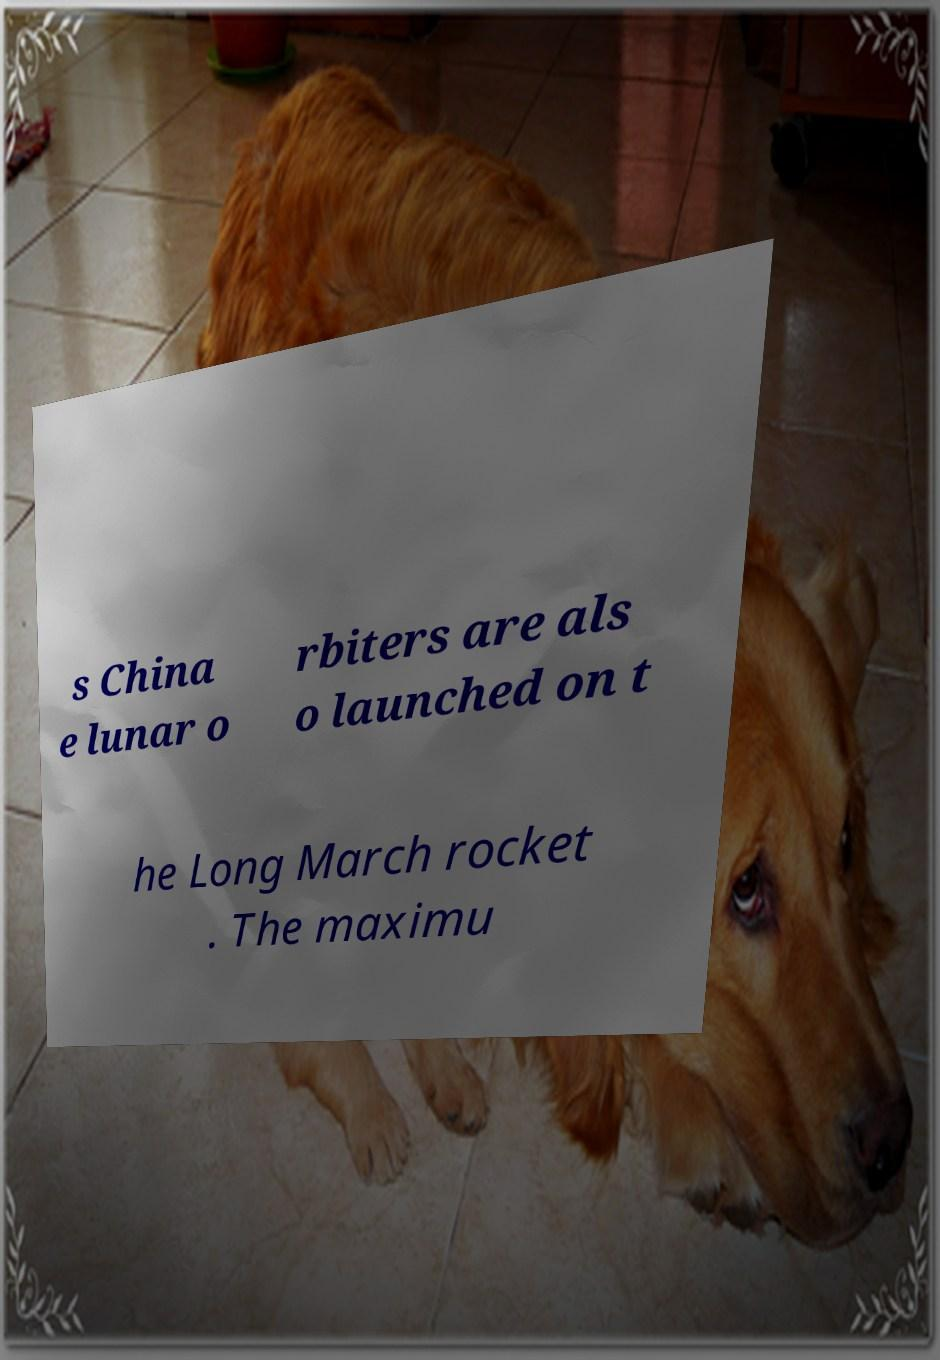For documentation purposes, I need the text within this image transcribed. Could you provide that? s China e lunar o rbiters are als o launched on t he Long March rocket . The maximu 